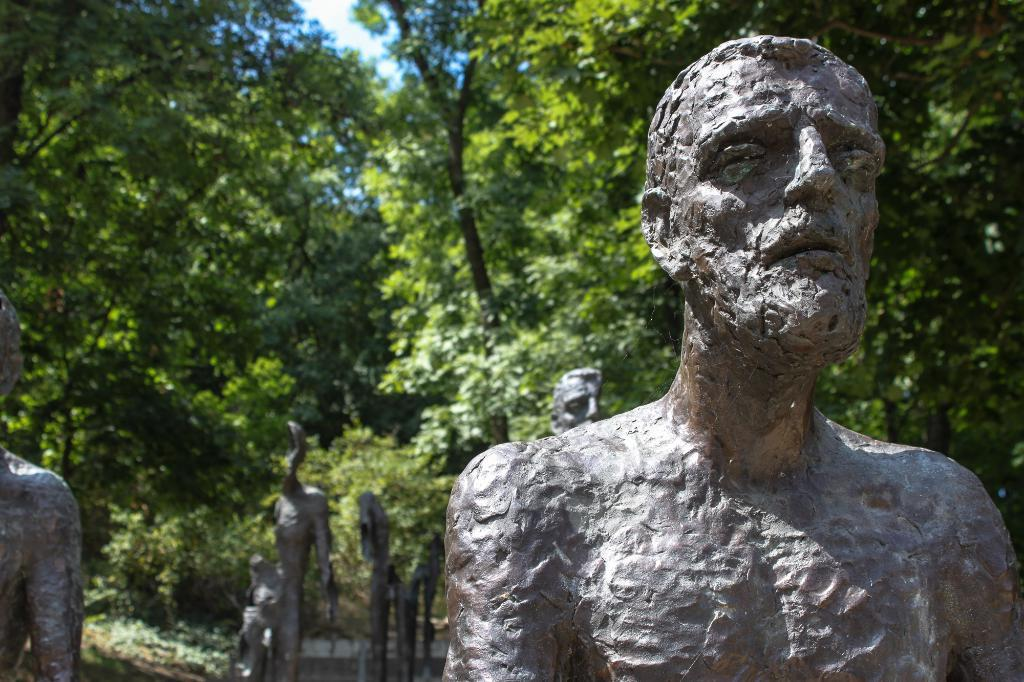What type of art is present in the foreground of the image? There are sculptures in the image. Where are the sculptures located in relation to the image? The sculptures are in the foreground of the image. What can be seen in the background of the image? There are trees and plants in the background of the image. What type of furniture is visible in the image? There is no furniture present in the image; it features sculptures in the foreground and trees and plants in the background. 